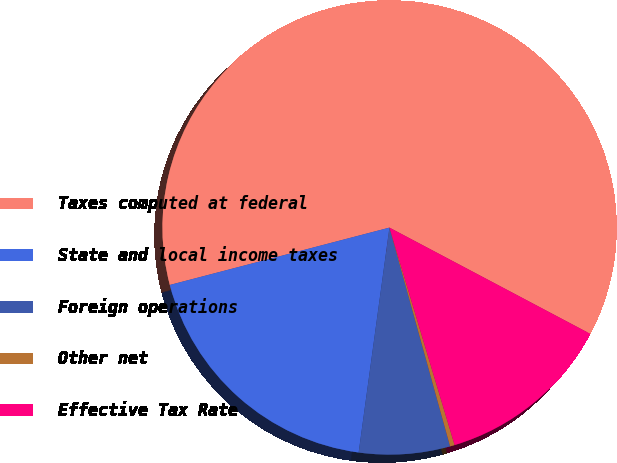<chart> <loc_0><loc_0><loc_500><loc_500><pie_chart><fcel>Taxes computed at federal<fcel>State and local income taxes<fcel>Foreign operations<fcel>Other net<fcel>Effective Tax Rate<nl><fcel>61.81%<fcel>18.77%<fcel>6.47%<fcel>0.33%<fcel>12.62%<nl></chart> 